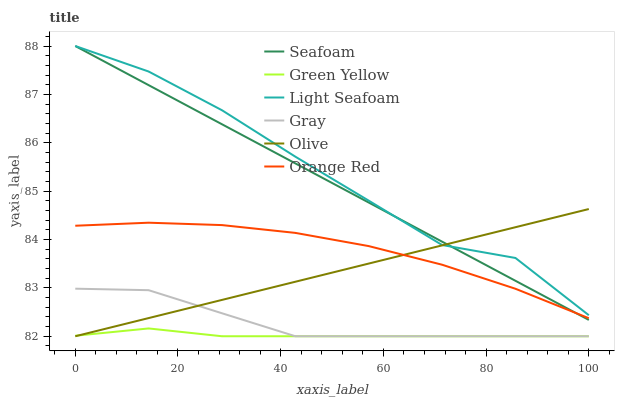Does Green Yellow have the minimum area under the curve?
Answer yes or no. Yes. Does Light Seafoam have the maximum area under the curve?
Answer yes or no. Yes. Does Seafoam have the minimum area under the curve?
Answer yes or no. No. Does Seafoam have the maximum area under the curve?
Answer yes or no. No. Is Seafoam the smoothest?
Answer yes or no. Yes. Is Light Seafoam the roughest?
Answer yes or no. Yes. Is Light Seafoam the smoothest?
Answer yes or no. No. Is Seafoam the roughest?
Answer yes or no. No. Does Gray have the lowest value?
Answer yes or no. Yes. Does Seafoam have the lowest value?
Answer yes or no. No. Does Seafoam have the highest value?
Answer yes or no. Yes. Does Olive have the highest value?
Answer yes or no. No. Is Gray less than Light Seafoam?
Answer yes or no. Yes. Is Light Seafoam greater than Gray?
Answer yes or no. Yes. Does Olive intersect Seafoam?
Answer yes or no. Yes. Is Olive less than Seafoam?
Answer yes or no. No. Is Olive greater than Seafoam?
Answer yes or no. No. Does Gray intersect Light Seafoam?
Answer yes or no. No. 